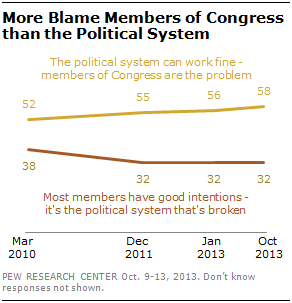Specify some key components in this picture. The red data point is always smaller than the yellow data point. The difference between yellow and red lines is increasing over the year, as indicated by the data. 